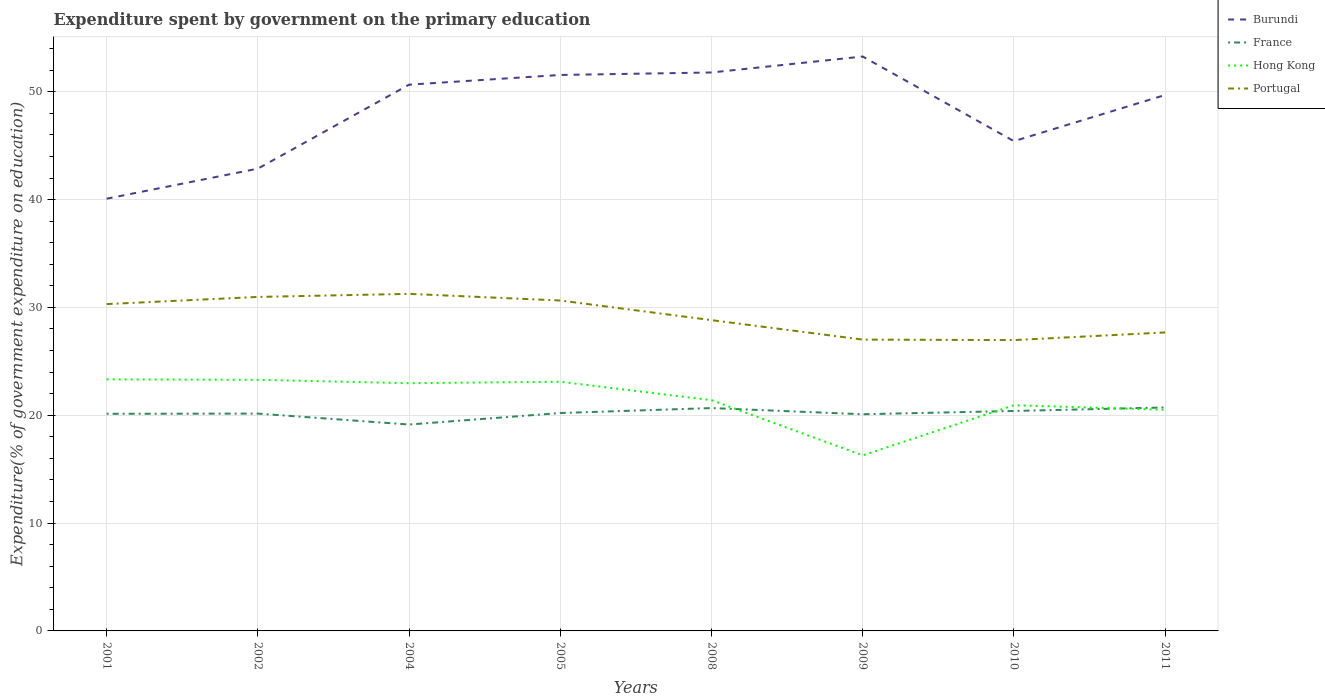Does the line corresponding to Portugal intersect with the line corresponding to Hong Kong?
Your answer should be compact. No. Is the number of lines equal to the number of legend labels?
Keep it short and to the point. Yes. Across all years, what is the maximum expenditure spent by government on the primary education in Burundi?
Provide a short and direct response. 40.08. What is the total expenditure spent by government on the primary education in Portugal in the graph?
Ensure brevity in your answer.  3.96. What is the difference between the highest and the second highest expenditure spent by government on the primary education in France?
Make the answer very short. 1.58. What is the difference between the highest and the lowest expenditure spent by government on the primary education in Hong Kong?
Your answer should be compact. 4. How many years are there in the graph?
Give a very brief answer. 8. What is the difference between two consecutive major ticks on the Y-axis?
Give a very brief answer. 10. Are the values on the major ticks of Y-axis written in scientific E-notation?
Keep it short and to the point. No. Does the graph contain any zero values?
Offer a very short reply. No. Does the graph contain grids?
Offer a terse response. Yes. Where does the legend appear in the graph?
Keep it short and to the point. Top right. What is the title of the graph?
Your response must be concise. Expenditure spent by government on the primary education. What is the label or title of the X-axis?
Your response must be concise. Years. What is the label or title of the Y-axis?
Your answer should be compact. Expenditure(% of government expenditure on education). What is the Expenditure(% of government expenditure on education) in Burundi in 2001?
Keep it short and to the point. 40.08. What is the Expenditure(% of government expenditure on education) of France in 2001?
Offer a very short reply. 20.13. What is the Expenditure(% of government expenditure on education) of Hong Kong in 2001?
Provide a short and direct response. 23.33. What is the Expenditure(% of government expenditure on education) of Portugal in 2001?
Your answer should be compact. 30.31. What is the Expenditure(% of government expenditure on education) of Burundi in 2002?
Provide a succinct answer. 42.87. What is the Expenditure(% of government expenditure on education) in France in 2002?
Keep it short and to the point. 20.15. What is the Expenditure(% of government expenditure on education) in Hong Kong in 2002?
Make the answer very short. 23.29. What is the Expenditure(% of government expenditure on education) in Portugal in 2002?
Ensure brevity in your answer.  30.97. What is the Expenditure(% of government expenditure on education) in Burundi in 2004?
Your response must be concise. 50.66. What is the Expenditure(% of government expenditure on education) of France in 2004?
Give a very brief answer. 19.14. What is the Expenditure(% of government expenditure on education) of Hong Kong in 2004?
Keep it short and to the point. 22.97. What is the Expenditure(% of government expenditure on education) of Portugal in 2004?
Offer a very short reply. 31.26. What is the Expenditure(% of government expenditure on education) of Burundi in 2005?
Provide a succinct answer. 51.56. What is the Expenditure(% of government expenditure on education) in France in 2005?
Your response must be concise. 20.21. What is the Expenditure(% of government expenditure on education) of Hong Kong in 2005?
Keep it short and to the point. 23.11. What is the Expenditure(% of government expenditure on education) in Portugal in 2005?
Keep it short and to the point. 30.64. What is the Expenditure(% of government expenditure on education) in Burundi in 2008?
Provide a short and direct response. 51.79. What is the Expenditure(% of government expenditure on education) in France in 2008?
Your response must be concise. 20.67. What is the Expenditure(% of government expenditure on education) in Hong Kong in 2008?
Your answer should be very brief. 21.4. What is the Expenditure(% of government expenditure on education) in Portugal in 2008?
Offer a terse response. 28.82. What is the Expenditure(% of government expenditure on education) of Burundi in 2009?
Make the answer very short. 53.27. What is the Expenditure(% of government expenditure on education) of France in 2009?
Provide a succinct answer. 20.09. What is the Expenditure(% of government expenditure on education) in Hong Kong in 2009?
Make the answer very short. 16.28. What is the Expenditure(% of government expenditure on education) of Portugal in 2009?
Provide a succinct answer. 27.02. What is the Expenditure(% of government expenditure on education) of Burundi in 2010?
Make the answer very short. 45.42. What is the Expenditure(% of government expenditure on education) in France in 2010?
Provide a short and direct response. 20.4. What is the Expenditure(% of government expenditure on education) in Hong Kong in 2010?
Your answer should be very brief. 20.93. What is the Expenditure(% of government expenditure on education) in Portugal in 2010?
Your answer should be very brief. 26.97. What is the Expenditure(% of government expenditure on education) in Burundi in 2011?
Your answer should be very brief. 49.7. What is the Expenditure(% of government expenditure on education) in France in 2011?
Make the answer very short. 20.72. What is the Expenditure(% of government expenditure on education) in Hong Kong in 2011?
Your answer should be compact. 20.51. What is the Expenditure(% of government expenditure on education) in Portugal in 2011?
Provide a short and direct response. 27.68. Across all years, what is the maximum Expenditure(% of government expenditure on education) in Burundi?
Give a very brief answer. 53.27. Across all years, what is the maximum Expenditure(% of government expenditure on education) in France?
Ensure brevity in your answer.  20.72. Across all years, what is the maximum Expenditure(% of government expenditure on education) of Hong Kong?
Keep it short and to the point. 23.33. Across all years, what is the maximum Expenditure(% of government expenditure on education) in Portugal?
Ensure brevity in your answer.  31.26. Across all years, what is the minimum Expenditure(% of government expenditure on education) of Burundi?
Your answer should be compact. 40.08. Across all years, what is the minimum Expenditure(% of government expenditure on education) of France?
Provide a short and direct response. 19.14. Across all years, what is the minimum Expenditure(% of government expenditure on education) in Hong Kong?
Offer a terse response. 16.28. Across all years, what is the minimum Expenditure(% of government expenditure on education) of Portugal?
Provide a short and direct response. 26.97. What is the total Expenditure(% of government expenditure on education) in Burundi in the graph?
Give a very brief answer. 385.34. What is the total Expenditure(% of government expenditure on education) in France in the graph?
Provide a short and direct response. 161.52. What is the total Expenditure(% of government expenditure on education) in Hong Kong in the graph?
Your response must be concise. 171.81. What is the total Expenditure(% of government expenditure on education) of Portugal in the graph?
Your answer should be very brief. 233.67. What is the difference between the Expenditure(% of government expenditure on education) of Burundi in 2001 and that in 2002?
Provide a short and direct response. -2.79. What is the difference between the Expenditure(% of government expenditure on education) of France in 2001 and that in 2002?
Offer a very short reply. -0.02. What is the difference between the Expenditure(% of government expenditure on education) of Hong Kong in 2001 and that in 2002?
Offer a terse response. 0.04. What is the difference between the Expenditure(% of government expenditure on education) of Portugal in 2001 and that in 2002?
Give a very brief answer. -0.66. What is the difference between the Expenditure(% of government expenditure on education) in Burundi in 2001 and that in 2004?
Ensure brevity in your answer.  -10.58. What is the difference between the Expenditure(% of government expenditure on education) in France in 2001 and that in 2004?
Your answer should be compact. 1. What is the difference between the Expenditure(% of government expenditure on education) in Hong Kong in 2001 and that in 2004?
Make the answer very short. 0.36. What is the difference between the Expenditure(% of government expenditure on education) of Portugal in 2001 and that in 2004?
Make the answer very short. -0.95. What is the difference between the Expenditure(% of government expenditure on education) in Burundi in 2001 and that in 2005?
Keep it short and to the point. -11.48. What is the difference between the Expenditure(% of government expenditure on education) in France in 2001 and that in 2005?
Your answer should be very brief. -0.07. What is the difference between the Expenditure(% of government expenditure on education) of Hong Kong in 2001 and that in 2005?
Make the answer very short. 0.22. What is the difference between the Expenditure(% of government expenditure on education) in Portugal in 2001 and that in 2005?
Your response must be concise. -0.33. What is the difference between the Expenditure(% of government expenditure on education) in Burundi in 2001 and that in 2008?
Make the answer very short. -11.71. What is the difference between the Expenditure(% of government expenditure on education) in France in 2001 and that in 2008?
Provide a short and direct response. -0.53. What is the difference between the Expenditure(% of government expenditure on education) of Hong Kong in 2001 and that in 2008?
Your answer should be very brief. 1.93. What is the difference between the Expenditure(% of government expenditure on education) in Portugal in 2001 and that in 2008?
Make the answer very short. 1.49. What is the difference between the Expenditure(% of government expenditure on education) of Burundi in 2001 and that in 2009?
Make the answer very short. -13.19. What is the difference between the Expenditure(% of government expenditure on education) in France in 2001 and that in 2009?
Give a very brief answer. 0.04. What is the difference between the Expenditure(% of government expenditure on education) of Hong Kong in 2001 and that in 2009?
Offer a terse response. 7.04. What is the difference between the Expenditure(% of government expenditure on education) in Portugal in 2001 and that in 2009?
Ensure brevity in your answer.  3.29. What is the difference between the Expenditure(% of government expenditure on education) in Burundi in 2001 and that in 2010?
Make the answer very short. -5.34. What is the difference between the Expenditure(% of government expenditure on education) of France in 2001 and that in 2010?
Offer a terse response. -0.26. What is the difference between the Expenditure(% of government expenditure on education) in Hong Kong in 2001 and that in 2010?
Your answer should be very brief. 2.4. What is the difference between the Expenditure(% of government expenditure on education) of Portugal in 2001 and that in 2010?
Offer a very short reply. 3.34. What is the difference between the Expenditure(% of government expenditure on education) of Burundi in 2001 and that in 2011?
Ensure brevity in your answer.  -9.62. What is the difference between the Expenditure(% of government expenditure on education) of France in 2001 and that in 2011?
Offer a very short reply. -0.59. What is the difference between the Expenditure(% of government expenditure on education) of Hong Kong in 2001 and that in 2011?
Your answer should be very brief. 2.82. What is the difference between the Expenditure(% of government expenditure on education) in Portugal in 2001 and that in 2011?
Keep it short and to the point. 2.63. What is the difference between the Expenditure(% of government expenditure on education) in Burundi in 2002 and that in 2004?
Your answer should be compact. -7.79. What is the difference between the Expenditure(% of government expenditure on education) in France in 2002 and that in 2004?
Keep it short and to the point. 1.01. What is the difference between the Expenditure(% of government expenditure on education) of Hong Kong in 2002 and that in 2004?
Provide a short and direct response. 0.31. What is the difference between the Expenditure(% of government expenditure on education) in Portugal in 2002 and that in 2004?
Make the answer very short. -0.28. What is the difference between the Expenditure(% of government expenditure on education) in Burundi in 2002 and that in 2005?
Give a very brief answer. -8.69. What is the difference between the Expenditure(% of government expenditure on education) in France in 2002 and that in 2005?
Your response must be concise. -0.05. What is the difference between the Expenditure(% of government expenditure on education) in Hong Kong in 2002 and that in 2005?
Give a very brief answer. 0.18. What is the difference between the Expenditure(% of government expenditure on education) in Portugal in 2002 and that in 2005?
Keep it short and to the point. 0.33. What is the difference between the Expenditure(% of government expenditure on education) of Burundi in 2002 and that in 2008?
Ensure brevity in your answer.  -8.92. What is the difference between the Expenditure(% of government expenditure on education) of France in 2002 and that in 2008?
Provide a short and direct response. -0.51. What is the difference between the Expenditure(% of government expenditure on education) in Hong Kong in 2002 and that in 2008?
Provide a succinct answer. 1.89. What is the difference between the Expenditure(% of government expenditure on education) of Portugal in 2002 and that in 2008?
Make the answer very short. 2.15. What is the difference between the Expenditure(% of government expenditure on education) in Burundi in 2002 and that in 2009?
Offer a very short reply. -10.4. What is the difference between the Expenditure(% of government expenditure on education) of France in 2002 and that in 2009?
Keep it short and to the point. 0.06. What is the difference between the Expenditure(% of government expenditure on education) of Hong Kong in 2002 and that in 2009?
Make the answer very short. 7. What is the difference between the Expenditure(% of government expenditure on education) of Portugal in 2002 and that in 2009?
Offer a terse response. 3.96. What is the difference between the Expenditure(% of government expenditure on education) of Burundi in 2002 and that in 2010?
Your answer should be very brief. -2.55. What is the difference between the Expenditure(% of government expenditure on education) in France in 2002 and that in 2010?
Your answer should be very brief. -0.24. What is the difference between the Expenditure(% of government expenditure on education) in Hong Kong in 2002 and that in 2010?
Your answer should be compact. 2.35. What is the difference between the Expenditure(% of government expenditure on education) of Portugal in 2002 and that in 2010?
Your answer should be very brief. 4. What is the difference between the Expenditure(% of government expenditure on education) in Burundi in 2002 and that in 2011?
Your answer should be very brief. -6.83. What is the difference between the Expenditure(% of government expenditure on education) in France in 2002 and that in 2011?
Your answer should be very brief. -0.57. What is the difference between the Expenditure(% of government expenditure on education) of Hong Kong in 2002 and that in 2011?
Offer a terse response. 2.78. What is the difference between the Expenditure(% of government expenditure on education) in Portugal in 2002 and that in 2011?
Your answer should be compact. 3.29. What is the difference between the Expenditure(% of government expenditure on education) in Burundi in 2004 and that in 2005?
Ensure brevity in your answer.  -0.9. What is the difference between the Expenditure(% of government expenditure on education) of France in 2004 and that in 2005?
Ensure brevity in your answer.  -1.07. What is the difference between the Expenditure(% of government expenditure on education) of Hong Kong in 2004 and that in 2005?
Your answer should be very brief. -0.13. What is the difference between the Expenditure(% of government expenditure on education) in Portugal in 2004 and that in 2005?
Ensure brevity in your answer.  0.62. What is the difference between the Expenditure(% of government expenditure on education) in Burundi in 2004 and that in 2008?
Provide a succinct answer. -1.13. What is the difference between the Expenditure(% of government expenditure on education) in France in 2004 and that in 2008?
Make the answer very short. -1.53. What is the difference between the Expenditure(% of government expenditure on education) in Hong Kong in 2004 and that in 2008?
Keep it short and to the point. 1.58. What is the difference between the Expenditure(% of government expenditure on education) of Portugal in 2004 and that in 2008?
Your answer should be compact. 2.44. What is the difference between the Expenditure(% of government expenditure on education) of Burundi in 2004 and that in 2009?
Make the answer very short. -2.61. What is the difference between the Expenditure(% of government expenditure on education) of France in 2004 and that in 2009?
Provide a short and direct response. -0.95. What is the difference between the Expenditure(% of government expenditure on education) of Hong Kong in 2004 and that in 2009?
Ensure brevity in your answer.  6.69. What is the difference between the Expenditure(% of government expenditure on education) in Portugal in 2004 and that in 2009?
Keep it short and to the point. 4.24. What is the difference between the Expenditure(% of government expenditure on education) in Burundi in 2004 and that in 2010?
Your answer should be compact. 5.24. What is the difference between the Expenditure(% of government expenditure on education) of France in 2004 and that in 2010?
Ensure brevity in your answer.  -1.26. What is the difference between the Expenditure(% of government expenditure on education) of Hong Kong in 2004 and that in 2010?
Make the answer very short. 2.04. What is the difference between the Expenditure(% of government expenditure on education) in Portugal in 2004 and that in 2010?
Keep it short and to the point. 4.29. What is the difference between the Expenditure(% of government expenditure on education) of Burundi in 2004 and that in 2011?
Offer a very short reply. 0.96. What is the difference between the Expenditure(% of government expenditure on education) in France in 2004 and that in 2011?
Your answer should be compact. -1.58. What is the difference between the Expenditure(% of government expenditure on education) in Hong Kong in 2004 and that in 2011?
Ensure brevity in your answer.  2.47. What is the difference between the Expenditure(% of government expenditure on education) in Portugal in 2004 and that in 2011?
Provide a short and direct response. 3.58. What is the difference between the Expenditure(% of government expenditure on education) of Burundi in 2005 and that in 2008?
Offer a terse response. -0.23. What is the difference between the Expenditure(% of government expenditure on education) in France in 2005 and that in 2008?
Provide a succinct answer. -0.46. What is the difference between the Expenditure(% of government expenditure on education) of Hong Kong in 2005 and that in 2008?
Keep it short and to the point. 1.71. What is the difference between the Expenditure(% of government expenditure on education) in Portugal in 2005 and that in 2008?
Keep it short and to the point. 1.82. What is the difference between the Expenditure(% of government expenditure on education) in Burundi in 2005 and that in 2009?
Offer a terse response. -1.71. What is the difference between the Expenditure(% of government expenditure on education) of France in 2005 and that in 2009?
Offer a terse response. 0.11. What is the difference between the Expenditure(% of government expenditure on education) of Hong Kong in 2005 and that in 2009?
Make the answer very short. 6.82. What is the difference between the Expenditure(% of government expenditure on education) of Portugal in 2005 and that in 2009?
Keep it short and to the point. 3.62. What is the difference between the Expenditure(% of government expenditure on education) of Burundi in 2005 and that in 2010?
Your answer should be very brief. 6.14. What is the difference between the Expenditure(% of government expenditure on education) in France in 2005 and that in 2010?
Your answer should be very brief. -0.19. What is the difference between the Expenditure(% of government expenditure on education) of Hong Kong in 2005 and that in 2010?
Provide a succinct answer. 2.18. What is the difference between the Expenditure(% of government expenditure on education) in Portugal in 2005 and that in 2010?
Your answer should be compact. 3.67. What is the difference between the Expenditure(% of government expenditure on education) in Burundi in 2005 and that in 2011?
Give a very brief answer. 1.86. What is the difference between the Expenditure(% of government expenditure on education) in France in 2005 and that in 2011?
Your answer should be very brief. -0.52. What is the difference between the Expenditure(% of government expenditure on education) in Hong Kong in 2005 and that in 2011?
Give a very brief answer. 2.6. What is the difference between the Expenditure(% of government expenditure on education) of Portugal in 2005 and that in 2011?
Provide a short and direct response. 2.96. What is the difference between the Expenditure(% of government expenditure on education) of Burundi in 2008 and that in 2009?
Your answer should be very brief. -1.48. What is the difference between the Expenditure(% of government expenditure on education) in France in 2008 and that in 2009?
Keep it short and to the point. 0.57. What is the difference between the Expenditure(% of government expenditure on education) of Hong Kong in 2008 and that in 2009?
Ensure brevity in your answer.  5.11. What is the difference between the Expenditure(% of government expenditure on education) of Portugal in 2008 and that in 2009?
Give a very brief answer. 1.81. What is the difference between the Expenditure(% of government expenditure on education) of Burundi in 2008 and that in 2010?
Give a very brief answer. 6.37. What is the difference between the Expenditure(% of government expenditure on education) in France in 2008 and that in 2010?
Offer a terse response. 0.27. What is the difference between the Expenditure(% of government expenditure on education) in Hong Kong in 2008 and that in 2010?
Your answer should be compact. 0.47. What is the difference between the Expenditure(% of government expenditure on education) in Portugal in 2008 and that in 2010?
Your answer should be compact. 1.85. What is the difference between the Expenditure(% of government expenditure on education) of Burundi in 2008 and that in 2011?
Offer a terse response. 2.09. What is the difference between the Expenditure(% of government expenditure on education) of France in 2008 and that in 2011?
Make the answer very short. -0.06. What is the difference between the Expenditure(% of government expenditure on education) in Hong Kong in 2008 and that in 2011?
Your response must be concise. 0.89. What is the difference between the Expenditure(% of government expenditure on education) of Portugal in 2008 and that in 2011?
Your answer should be compact. 1.14. What is the difference between the Expenditure(% of government expenditure on education) of Burundi in 2009 and that in 2010?
Offer a terse response. 7.85. What is the difference between the Expenditure(% of government expenditure on education) of France in 2009 and that in 2010?
Ensure brevity in your answer.  -0.31. What is the difference between the Expenditure(% of government expenditure on education) in Hong Kong in 2009 and that in 2010?
Make the answer very short. -4.65. What is the difference between the Expenditure(% of government expenditure on education) of Portugal in 2009 and that in 2010?
Provide a succinct answer. 0.04. What is the difference between the Expenditure(% of government expenditure on education) in Burundi in 2009 and that in 2011?
Your answer should be very brief. 3.57. What is the difference between the Expenditure(% of government expenditure on education) in France in 2009 and that in 2011?
Provide a succinct answer. -0.63. What is the difference between the Expenditure(% of government expenditure on education) of Hong Kong in 2009 and that in 2011?
Your answer should be very brief. -4.22. What is the difference between the Expenditure(% of government expenditure on education) in Portugal in 2009 and that in 2011?
Offer a very short reply. -0.66. What is the difference between the Expenditure(% of government expenditure on education) of Burundi in 2010 and that in 2011?
Your answer should be very brief. -4.28. What is the difference between the Expenditure(% of government expenditure on education) in France in 2010 and that in 2011?
Make the answer very short. -0.32. What is the difference between the Expenditure(% of government expenditure on education) of Hong Kong in 2010 and that in 2011?
Your answer should be compact. 0.42. What is the difference between the Expenditure(% of government expenditure on education) in Portugal in 2010 and that in 2011?
Offer a very short reply. -0.71. What is the difference between the Expenditure(% of government expenditure on education) of Burundi in 2001 and the Expenditure(% of government expenditure on education) of France in 2002?
Offer a terse response. 19.93. What is the difference between the Expenditure(% of government expenditure on education) of Burundi in 2001 and the Expenditure(% of government expenditure on education) of Hong Kong in 2002?
Offer a very short reply. 16.8. What is the difference between the Expenditure(% of government expenditure on education) in Burundi in 2001 and the Expenditure(% of government expenditure on education) in Portugal in 2002?
Provide a succinct answer. 9.11. What is the difference between the Expenditure(% of government expenditure on education) in France in 2001 and the Expenditure(% of government expenditure on education) in Hong Kong in 2002?
Give a very brief answer. -3.15. What is the difference between the Expenditure(% of government expenditure on education) of France in 2001 and the Expenditure(% of government expenditure on education) of Portugal in 2002?
Provide a succinct answer. -10.84. What is the difference between the Expenditure(% of government expenditure on education) of Hong Kong in 2001 and the Expenditure(% of government expenditure on education) of Portugal in 2002?
Your response must be concise. -7.65. What is the difference between the Expenditure(% of government expenditure on education) of Burundi in 2001 and the Expenditure(% of government expenditure on education) of France in 2004?
Provide a succinct answer. 20.94. What is the difference between the Expenditure(% of government expenditure on education) of Burundi in 2001 and the Expenditure(% of government expenditure on education) of Hong Kong in 2004?
Your answer should be compact. 17.11. What is the difference between the Expenditure(% of government expenditure on education) in Burundi in 2001 and the Expenditure(% of government expenditure on education) in Portugal in 2004?
Give a very brief answer. 8.83. What is the difference between the Expenditure(% of government expenditure on education) in France in 2001 and the Expenditure(% of government expenditure on education) in Hong Kong in 2004?
Your response must be concise. -2.84. What is the difference between the Expenditure(% of government expenditure on education) in France in 2001 and the Expenditure(% of government expenditure on education) in Portugal in 2004?
Provide a short and direct response. -11.12. What is the difference between the Expenditure(% of government expenditure on education) in Hong Kong in 2001 and the Expenditure(% of government expenditure on education) in Portugal in 2004?
Make the answer very short. -7.93. What is the difference between the Expenditure(% of government expenditure on education) of Burundi in 2001 and the Expenditure(% of government expenditure on education) of France in 2005?
Your response must be concise. 19.87. What is the difference between the Expenditure(% of government expenditure on education) of Burundi in 2001 and the Expenditure(% of government expenditure on education) of Hong Kong in 2005?
Ensure brevity in your answer.  16.97. What is the difference between the Expenditure(% of government expenditure on education) of Burundi in 2001 and the Expenditure(% of government expenditure on education) of Portugal in 2005?
Give a very brief answer. 9.44. What is the difference between the Expenditure(% of government expenditure on education) in France in 2001 and the Expenditure(% of government expenditure on education) in Hong Kong in 2005?
Provide a succinct answer. -2.97. What is the difference between the Expenditure(% of government expenditure on education) of France in 2001 and the Expenditure(% of government expenditure on education) of Portugal in 2005?
Make the answer very short. -10.51. What is the difference between the Expenditure(% of government expenditure on education) in Hong Kong in 2001 and the Expenditure(% of government expenditure on education) in Portugal in 2005?
Your response must be concise. -7.31. What is the difference between the Expenditure(% of government expenditure on education) of Burundi in 2001 and the Expenditure(% of government expenditure on education) of France in 2008?
Ensure brevity in your answer.  19.42. What is the difference between the Expenditure(% of government expenditure on education) in Burundi in 2001 and the Expenditure(% of government expenditure on education) in Hong Kong in 2008?
Provide a succinct answer. 18.68. What is the difference between the Expenditure(% of government expenditure on education) of Burundi in 2001 and the Expenditure(% of government expenditure on education) of Portugal in 2008?
Offer a terse response. 11.26. What is the difference between the Expenditure(% of government expenditure on education) of France in 2001 and the Expenditure(% of government expenditure on education) of Hong Kong in 2008?
Your answer should be very brief. -1.26. What is the difference between the Expenditure(% of government expenditure on education) of France in 2001 and the Expenditure(% of government expenditure on education) of Portugal in 2008?
Your answer should be compact. -8.69. What is the difference between the Expenditure(% of government expenditure on education) in Hong Kong in 2001 and the Expenditure(% of government expenditure on education) in Portugal in 2008?
Provide a short and direct response. -5.49. What is the difference between the Expenditure(% of government expenditure on education) in Burundi in 2001 and the Expenditure(% of government expenditure on education) in France in 2009?
Your answer should be very brief. 19.99. What is the difference between the Expenditure(% of government expenditure on education) in Burundi in 2001 and the Expenditure(% of government expenditure on education) in Hong Kong in 2009?
Offer a very short reply. 23.8. What is the difference between the Expenditure(% of government expenditure on education) in Burundi in 2001 and the Expenditure(% of government expenditure on education) in Portugal in 2009?
Offer a very short reply. 13.07. What is the difference between the Expenditure(% of government expenditure on education) in France in 2001 and the Expenditure(% of government expenditure on education) in Hong Kong in 2009?
Offer a very short reply. 3.85. What is the difference between the Expenditure(% of government expenditure on education) in France in 2001 and the Expenditure(% of government expenditure on education) in Portugal in 2009?
Give a very brief answer. -6.88. What is the difference between the Expenditure(% of government expenditure on education) of Hong Kong in 2001 and the Expenditure(% of government expenditure on education) of Portugal in 2009?
Provide a short and direct response. -3.69. What is the difference between the Expenditure(% of government expenditure on education) of Burundi in 2001 and the Expenditure(% of government expenditure on education) of France in 2010?
Keep it short and to the point. 19.68. What is the difference between the Expenditure(% of government expenditure on education) of Burundi in 2001 and the Expenditure(% of government expenditure on education) of Hong Kong in 2010?
Make the answer very short. 19.15. What is the difference between the Expenditure(% of government expenditure on education) in Burundi in 2001 and the Expenditure(% of government expenditure on education) in Portugal in 2010?
Your response must be concise. 13.11. What is the difference between the Expenditure(% of government expenditure on education) in France in 2001 and the Expenditure(% of government expenditure on education) in Hong Kong in 2010?
Ensure brevity in your answer.  -0.8. What is the difference between the Expenditure(% of government expenditure on education) in France in 2001 and the Expenditure(% of government expenditure on education) in Portugal in 2010?
Your response must be concise. -6.84. What is the difference between the Expenditure(% of government expenditure on education) of Hong Kong in 2001 and the Expenditure(% of government expenditure on education) of Portugal in 2010?
Your answer should be compact. -3.64. What is the difference between the Expenditure(% of government expenditure on education) of Burundi in 2001 and the Expenditure(% of government expenditure on education) of France in 2011?
Keep it short and to the point. 19.36. What is the difference between the Expenditure(% of government expenditure on education) of Burundi in 2001 and the Expenditure(% of government expenditure on education) of Hong Kong in 2011?
Your response must be concise. 19.58. What is the difference between the Expenditure(% of government expenditure on education) in Burundi in 2001 and the Expenditure(% of government expenditure on education) in Portugal in 2011?
Give a very brief answer. 12.4. What is the difference between the Expenditure(% of government expenditure on education) of France in 2001 and the Expenditure(% of government expenditure on education) of Hong Kong in 2011?
Provide a short and direct response. -0.37. What is the difference between the Expenditure(% of government expenditure on education) in France in 2001 and the Expenditure(% of government expenditure on education) in Portugal in 2011?
Provide a short and direct response. -7.54. What is the difference between the Expenditure(% of government expenditure on education) in Hong Kong in 2001 and the Expenditure(% of government expenditure on education) in Portugal in 2011?
Provide a short and direct response. -4.35. What is the difference between the Expenditure(% of government expenditure on education) in Burundi in 2002 and the Expenditure(% of government expenditure on education) in France in 2004?
Provide a short and direct response. 23.73. What is the difference between the Expenditure(% of government expenditure on education) of Burundi in 2002 and the Expenditure(% of government expenditure on education) of Hong Kong in 2004?
Your response must be concise. 19.9. What is the difference between the Expenditure(% of government expenditure on education) in Burundi in 2002 and the Expenditure(% of government expenditure on education) in Portugal in 2004?
Keep it short and to the point. 11.61. What is the difference between the Expenditure(% of government expenditure on education) in France in 2002 and the Expenditure(% of government expenditure on education) in Hong Kong in 2004?
Offer a very short reply. -2.82. What is the difference between the Expenditure(% of government expenditure on education) in France in 2002 and the Expenditure(% of government expenditure on education) in Portugal in 2004?
Offer a terse response. -11.1. What is the difference between the Expenditure(% of government expenditure on education) of Hong Kong in 2002 and the Expenditure(% of government expenditure on education) of Portugal in 2004?
Ensure brevity in your answer.  -7.97. What is the difference between the Expenditure(% of government expenditure on education) in Burundi in 2002 and the Expenditure(% of government expenditure on education) in France in 2005?
Your answer should be very brief. 22.66. What is the difference between the Expenditure(% of government expenditure on education) of Burundi in 2002 and the Expenditure(% of government expenditure on education) of Hong Kong in 2005?
Offer a terse response. 19.76. What is the difference between the Expenditure(% of government expenditure on education) in Burundi in 2002 and the Expenditure(% of government expenditure on education) in Portugal in 2005?
Your response must be concise. 12.23. What is the difference between the Expenditure(% of government expenditure on education) of France in 2002 and the Expenditure(% of government expenditure on education) of Hong Kong in 2005?
Keep it short and to the point. -2.95. What is the difference between the Expenditure(% of government expenditure on education) in France in 2002 and the Expenditure(% of government expenditure on education) in Portugal in 2005?
Offer a very short reply. -10.49. What is the difference between the Expenditure(% of government expenditure on education) of Hong Kong in 2002 and the Expenditure(% of government expenditure on education) of Portugal in 2005?
Ensure brevity in your answer.  -7.36. What is the difference between the Expenditure(% of government expenditure on education) in Burundi in 2002 and the Expenditure(% of government expenditure on education) in France in 2008?
Make the answer very short. 22.2. What is the difference between the Expenditure(% of government expenditure on education) of Burundi in 2002 and the Expenditure(% of government expenditure on education) of Hong Kong in 2008?
Your answer should be very brief. 21.47. What is the difference between the Expenditure(% of government expenditure on education) in Burundi in 2002 and the Expenditure(% of government expenditure on education) in Portugal in 2008?
Give a very brief answer. 14.05. What is the difference between the Expenditure(% of government expenditure on education) of France in 2002 and the Expenditure(% of government expenditure on education) of Hong Kong in 2008?
Offer a very short reply. -1.24. What is the difference between the Expenditure(% of government expenditure on education) of France in 2002 and the Expenditure(% of government expenditure on education) of Portugal in 2008?
Provide a succinct answer. -8.67. What is the difference between the Expenditure(% of government expenditure on education) of Hong Kong in 2002 and the Expenditure(% of government expenditure on education) of Portugal in 2008?
Keep it short and to the point. -5.54. What is the difference between the Expenditure(% of government expenditure on education) of Burundi in 2002 and the Expenditure(% of government expenditure on education) of France in 2009?
Your response must be concise. 22.78. What is the difference between the Expenditure(% of government expenditure on education) in Burundi in 2002 and the Expenditure(% of government expenditure on education) in Hong Kong in 2009?
Offer a very short reply. 26.59. What is the difference between the Expenditure(% of government expenditure on education) of Burundi in 2002 and the Expenditure(% of government expenditure on education) of Portugal in 2009?
Your response must be concise. 15.85. What is the difference between the Expenditure(% of government expenditure on education) in France in 2002 and the Expenditure(% of government expenditure on education) in Hong Kong in 2009?
Ensure brevity in your answer.  3.87. What is the difference between the Expenditure(% of government expenditure on education) of France in 2002 and the Expenditure(% of government expenditure on education) of Portugal in 2009?
Your answer should be compact. -6.86. What is the difference between the Expenditure(% of government expenditure on education) in Hong Kong in 2002 and the Expenditure(% of government expenditure on education) in Portugal in 2009?
Provide a succinct answer. -3.73. What is the difference between the Expenditure(% of government expenditure on education) of Burundi in 2002 and the Expenditure(% of government expenditure on education) of France in 2010?
Your answer should be compact. 22.47. What is the difference between the Expenditure(% of government expenditure on education) of Burundi in 2002 and the Expenditure(% of government expenditure on education) of Hong Kong in 2010?
Make the answer very short. 21.94. What is the difference between the Expenditure(% of government expenditure on education) of Burundi in 2002 and the Expenditure(% of government expenditure on education) of Portugal in 2010?
Your response must be concise. 15.9. What is the difference between the Expenditure(% of government expenditure on education) of France in 2002 and the Expenditure(% of government expenditure on education) of Hong Kong in 2010?
Make the answer very short. -0.78. What is the difference between the Expenditure(% of government expenditure on education) of France in 2002 and the Expenditure(% of government expenditure on education) of Portugal in 2010?
Provide a short and direct response. -6.82. What is the difference between the Expenditure(% of government expenditure on education) in Hong Kong in 2002 and the Expenditure(% of government expenditure on education) in Portugal in 2010?
Keep it short and to the point. -3.69. What is the difference between the Expenditure(% of government expenditure on education) of Burundi in 2002 and the Expenditure(% of government expenditure on education) of France in 2011?
Your answer should be very brief. 22.15. What is the difference between the Expenditure(% of government expenditure on education) of Burundi in 2002 and the Expenditure(% of government expenditure on education) of Hong Kong in 2011?
Ensure brevity in your answer.  22.36. What is the difference between the Expenditure(% of government expenditure on education) of Burundi in 2002 and the Expenditure(% of government expenditure on education) of Portugal in 2011?
Keep it short and to the point. 15.19. What is the difference between the Expenditure(% of government expenditure on education) of France in 2002 and the Expenditure(% of government expenditure on education) of Hong Kong in 2011?
Your answer should be compact. -0.35. What is the difference between the Expenditure(% of government expenditure on education) in France in 2002 and the Expenditure(% of government expenditure on education) in Portugal in 2011?
Offer a very short reply. -7.53. What is the difference between the Expenditure(% of government expenditure on education) of Hong Kong in 2002 and the Expenditure(% of government expenditure on education) of Portugal in 2011?
Your response must be concise. -4.39. What is the difference between the Expenditure(% of government expenditure on education) of Burundi in 2004 and the Expenditure(% of government expenditure on education) of France in 2005?
Your answer should be compact. 30.45. What is the difference between the Expenditure(% of government expenditure on education) of Burundi in 2004 and the Expenditure(% of government expenditure on education) of Hong Kong in 2005?
Offer a very short reply. 27.55. What is the difference between the Expenditure(% of government expenditure on education) of Burundi in 2004 and the Expenditure(% of government expenditure on education) of Portugal in 2005?
Provide a succinct answer. 20.02. What is the difference between the Expenditure(% of government expenditure on education) of France in 2004 and the Expenditure(% of government expenditure on education) of Hong Kong in 2005?
Provide a short and direct response. -3.97. What is the difference between the Expenditure(% of government expenditure on education) in France in 2004 and the Expenditure(% of government expenditure on education) in Portugal in 2005?
Your answer should be compact. -11.5. What is the difference between the Expenditure(% of government expenditure on education) of Hong Kong in 2004 and the Expenditure(% of government expenditure on education) of Portugal in 2005?
Keep it short and to the point. -7.67. What is the difference between the Expenditure(% of government expenditure on education) of Burundi in 2004 and the Expenditure(% of government expenditure on education) of France in 2008?
Offer a very short reply. 29.99. What is the difference between the Expenditure(% of government expenditure on education) of Burundi in 2004 and the Expenditure(% of government expenditure on education) of Hong Kong in 2008?
Provide a short and direct response. 29.26. What is the difference between the Expenditure(% of government expenditure on education) in Burundi in 2004 and the Expenditure(% of government expenditure on education) in Portugal in 2008?
Your response must be concise. 21.84. What is the difference between the Expenditure(% of government expenditure on education) in France in 2004 and the Expenditure(% of government expenditure on education) in Hong Kong in 2008?
Provide a short and direct response. -2.26. What is the difference between the Expenditure(% of government expenditure on education) in France in 2004 and the Expenditure(% of government expenditure on education) in Portugal in 2008?
Provide a succinct answer. -9.68. What is the difference between the Expenditure(% of government expenditure on education) of Hong Kong in 2004 and the Expenditure(% of government expenditure on education) of Portugal in 2008?
Offer a very short reply. -5.85. What is the difference between the Expenditure(% of government expenditure on education) of Burundi in 2004 and the Expenditure(% of government expenditure on education) of France in 2009?
Make the answer very short. 30.56. What is the difference between the Expenditure(% of government expenditure on education) of Burundi in 2004 and the Expenditure(% of government expenditure on education) of Hong Kong in 2009?
Keep it short and to the point. 34.37. What is the difference between the Expenditure(% of government expenditure on education) of Burundi in 2004 and the Expenditure(% of government expenditure on education) of Portugal in 2009?
Ensure brevity in your answer.  23.64. What is the difference between the Expenditure(% of government expenditure on education) of France in 2004 and the Expenditure(% of government expenditure on education) of Hong Kong in 2009?
Provide a succinct answer. 2.86. What is the difference between the Expenditure(% of government expenditure on education) of France in 2004 and the Expenditure(% of government expenditure on education) of Portugal in 2009?
Keep it short and to the point. -7.88. What is the difference between the Expenditure(% of government expenditure on education) of Hong Kong in 2004 and the Expenditure(% of government expenditure on education) of Portugal in 2009?
Your response must be concise. -4.04. What is the difference between the Expenditure(% of government expenditure on education) of Burundi in 2004 and the Expenditure(% of government expenditure on education) of France in 2010?
Keep it short and to the point. 30.26. What is the difference between the Expenditure(% of government expenditure on education) of Burundi in 2004 and the Expenditure(% of government expenditure on education) of Hong Kong in 2010?
Provide a short and direct response. 29.73. What is the difference between the Expenditure(% of government expenditure on education) in Burundi in 2004 and the Expenditure(% of government expenditure on education) in Portugal in 2010?
Ensure brevity in your answer.  23.69. What is the difference between the Expenditure(% of government expenditure on education) of France in 2004 and the Expenditure(% of government expenditure on education) of Hong Kong in 2010?
Provide a short and direct response. -1.79. What is the difference between the Expenditure(% of government expenditure on education) in France in 2004 and the Expenditure(% of government expenditure on education) in Portugal in 2010?
Offer a terse response. -7.83. What is the difference between the Expenditure(% of government expenditure on education) in Hong Kong in 2004 and the Expenditure(% of government expenditure on education) in Portugal in 2010?
Your answer should be compact. -4. What is the difference between the Expenditure(% of government expenditure on education) of Burundi in 2004 and the Expenditure(% of government expenditure on education) of France in 2011?
Your answer should be very brief. 29.93. What is the difference between the Expenditure(% of government expenditure on education) of Burundi in 2004 and the Expenditure(% of government expenditure on education) of Hong Kong in 2011?
Give a very brief answer. 30.15. What is the difference between the Expenditure(% of government expenditure on education) in Burundi in 2004 and the Expenditure(% of government expenditure on education) in Portugal in 2011?
Your answer should be compact. 22.98. What is the difference between the Expenditure(% of government expenditure on education) in France in 2004 and the Expenditure(% of government expenditure on education) in Hong Kong in 2011?
Provide a short and direct response. -1.37. What is the difference between the Expenditure(% of government expenditure on education) of France in 2004 and the Expenditure(% of government expenditure on education) of Portugal in 2011?
Keep it short and to the point. -8.54. What is the difference between the Expenditure(% of government expenditure on education) in Hong Kong in 2004 and the Expenditure(% of government expenditure on education) in Portugal in 2011?
Your answer should be very brief. -4.71. What is the difference between the Expenditure(% of government expenditure on education) of Burundi in 2005 and the Expenditure(% of government expenditure on education) of France in 2008?
Your answer should be very brief. 30.89. What is the difference between the Expenditure(% of government expenditure on education) in Burundi in 2005 and the Expenditure(% of government expenditure on education) in Hong Kong in 2008?
Offer a terse response. 30.16. What is the difference between the Expenditure(% of government expenditure on education) in Burundi in 2005 and the Expenditure(% of government expenditure on education) in Portugal in 2008?
Offer a very short reply. 22.74. What is the difference between the Expenditure(% of government expenditure on education) in France in 2005 and the Expenditure(% of government expenditure on education) in Hong Kong in 2008?
Provide a succinct answer. -1.19. What is the difference between the Expenditure(% of government expenditure on education) in France in 2005 and the Expenditure(% of government expenditure on education) in Portugal in 2008?
Your response must be concise. -8.61. What is the difference between the Expenditure(% of government expenditure on education) in Hong Kong in 2005 and the Expenditure(% of government expenditure on education) in Portugal in 2008?
Keep it short and to the point. -5.71. What is the difference between the Expenditure(% of government expenditure on education) in Burundi in 2005 and the Expenditure(% of government expenditure on education) in France in 2009?
Make the answer very short. 31.46. What is the difference between the Expenditure(% of government expenditure on education) of Burundi in 2005 and the Expenditure(% of government expenditure on education) of Hong Kong in 2009?
Ensure brevity in your answer.  35.27. What is the difference between the Expenditure(% of government expenditure on education) in Burundi in 2005 and the Expenditure(% of government expenditure on education) in Portugal in 2009?
Ensure brevity in your answer.  24.54. What is the difference between the Expenditure(% of government expenditure on education) in France in 2005 and the Expenditure(% of government expenditure on education) in Hong Kong in 2009?
Your response must be concise. 3.92. What is the difference between the Expenditure(% of government expenditure on education) in France in 2005 and the Expenditure(% of government expenditure on education) in Portugal in 2009?
Your answer should be compact. -6.81. What is the difference between the Expenditure(% of government expenditure on education) in Hong Kong in 2005 and the Expenditure(% of government expenditure on education) in Portugal in 2009?
Make the answer very short. -3.91. What is the difference between the Expenditure(% of government expenditure on education) in Burundi in 2005 and the Expenditure(% of government expenditure on education) in France in 2010?
Keep it short and to the point. 31.16. What is the difference between the Expenditure(% of government expenditure on education) in Burundi in 2005 and the Expenditure(% of government expenditure on education) in Hong Kong in 2010?
Offer a terse response. 30.63. What is the difference between the Expenditure(% of government expenditure on education) of Burundi in 2005 and the Expenditure(% of government expenditure on education) of Portugal in 2010?
Keep it short and to the point. 24.59. What is the difference between the Expenditure(% of government expenditure on education) in France in 2005 and the Expenditure(% of government expenditure on education) in Hong Kong in 2010?
Your answer should be compact. -0.72. What is the difference between the Expenditure(% of government expenditure on education) in France in 2005 and the Expenditure(% of government expenditure on education) in Portugal in 2010?
Provide a succinct answer. -6.76. What is the difference between the Expenditure(% of government expenditure on education) of Hong Kong in 2005 and the Expenditure(% of government expenditure on education) of Portugal in 2010?
Provide a short and direct response. -3.86. What is the difference between the Expenditure(% of government expenditure on education) of Burundi in 2005 and the Expenditure(% of government expenditure on education) of France in 2011?
Make the answer very short. 30.83. What is the difference between the Expenditure(% of government expenditure on education) in Burundi in 2005 and the Expenditure(% of government expenditure on education) in Hong Kong in 2011?
Ensure brevity in your answer.  31.05. What is the difference between the Expenditure(% of government expenditure on education) in Burundi in 2005 and the Expenditure(% of government expenditure on education) in Portugal in 2011?
Give a very brief answer. 23.88. What is the difference between the Expenditure(% of government expenditure on education) of France in 2005 and the Expenditure(% of government expenditure on education) of Hong Kong in 2011?
Provide a succinct answer. -0.3. What is the difference between the Expenditure(% of government expenditure on education) of France in 2005 and the Expenditure(% of government expenditure on education) of Portugal in 2011?
Provide a succinct answer. -7.47. What is the difference between the Expenditure(% of government expenditure on education) of Hong Kong in 2005 and the Expenditure(% of government expenditure on education) of Portugal in 2011?
Your answer should be compact. -4.57. What is the difference between the Expenditure(% of government expenditure on education) in Burundi in 2008 and the Expenditure(% of government expenditure on education) in France in 2009?
Give a very brief answer. 31.69. What is the difference between the Expenditure(% of government expenditure on education) of Burundi in 2008 and the Expenditure(% of government expenditure on education) of Hong Kong in 2009?
Your answer should be compact. 35.5. What is the difference between the Expenditure(% of government expenditure on education) of Burundi in 2008 and the Expenditure(% of government expenditure on education) of Portugal in 2009?
Provide a short and direct response. 24.77. What is the difference between the Expenditure(% of government expenditure on education) in France in 2008 and the Expenditure(% of government expenditure on education) in Hong Kong in 2009?
Ensure brevity in your answer.  4.38. What is the difference between the Expenditure(% of government expenditure on education) of France in 2008 and the Expenditure(% of government expenditure on education) of Portugal in 2009?
Your answer should be very brief. -6.35. What is the difference between the Expenditure(% of government expenditure on education) of Hong Kong in 2008 and the Expenditure(% of government expenditure on education) of Portugal in 2009?
Your answer should be compact. -5.62. What is the difference between the Expenditure(% of government expenditure on education) of Burundi in 2008 and the Expenditure(% of government expenditure on education) of France in 2010?
Offer a very short reply. 31.39. What is the difference between the Expenditure(% of government expenditure on education) of Burundi in 2008 and the Expenditure(% of government expenditure on education) of Hong Kong in 2010?
Offer a terse response. 30.86. What is the difference between the Expenditure(% of government expenditure on education) in Burundi in 2008 and the Expenditure(% of government expenditure on education) in Portugal in 2010?
Give a very brief answer. 24.82. What is the difference between the Expenditure(% of government expenditure on education) of France in 2008 and the Expenditure(% of government expenditure on education) of Hong Kong in 2010?
Ensure brevity in your answer.  -0.26. What is the difference between the Expenditure(% of government expenditure on education) of France in 2008 and the Expenditure(% of government expenditure on education) of Portugal in 2010?
Make the answer very short. -6.3. What is the difference between the Expenditure(% of government expenditure on education) of Hong Kong in 2008 and the Expenditure(% of government expenditure on education) of Portugal in 2010?
Give a very brief answer. -5.57. What is the difference between the Expenditure(% of government expenditure on education) of Burundi in 2008 and the Expenditure(% of government expenditure on education) of France in 2011?
Your answer should be very brief. 31.06. What is the difference between the Expenditure(% of government expenditure on education) of Burundi in 2008 and the Expenditure(% of government expenditure on education) of Hong Kong in 2011?
Offer a very short reply. 31.28. What is the difference between the Expenditure(% of government expenditure on education) in Burundi in 2008 and the Expenditure(% of government expenditure on education) in Portugal in 2011?
Provide a short and direct response. 24.11. What is the difference between the Expenditure(% of government expenditure on education) of France in 2008 and the Expenditure(% of government expenditure on education) of Hong Kong in 2011?
Your answer should be very brief. 0.16. What is the difference between the Expenditure(% of government expenditure on education) in France in 2008 and the Expenditure(% of government expenditure on education) in Portugal in 2011?
Your answer should be very brief. -7.01. What is the difference between the Expenditure(% of government expenditure on education) in Hong Kong in 2008 and the Expenditure(% of government expenditure on education) in Portugal in 2011?
Offer a terse response. -6.28. What is the difference between the Expenditure(% of government expenditure on education) in Burundi in 2009 and the Expenditure(% of government expenditure on education) in France in 2010?
Keep it short and to the point. 32.87. What is the difference between the Expenditure(% of government expenditure on education) in Burundi in 2009 and the Expenditure(% of government expenditure on education) in Hong Kong in 2010?
Offer a very short reply. 32.34. What is the difference between the Expenditure(% of government expenditure on education) of Burundi in 2009 and the Expenditure(% of government expenditure on education) of Portugal in 2010?
Keep it short and to the point. 26.3. What is the difference between the Expenditure(% of government expenditure on education) of France in 2009 and the Expenditure(% of government expenditure on education) of Hong Kong in 2010?
Ensure brevity in your answer.  -0.84. What is the difference between the Expenditure(% of government expenditure on education) of France in 2009 and the Expenditure(% of government expenditure on education) of Portugal in 2010?
Provide a succinct answer. -6.88. What is the difference between the Expenditure(% of government expenditure on education) of Hong Kong in 2009 and the Expenditure(% of government expenditure on education) of Portugal in 2010?
Provide a succinct answer. -10.69. What is the difference between the Expenditure(% of government expenditure on education) of Burundi in 2009 and the Expenditure(% of government expenditure on education) of France in 2011?
Offer a terse response. 32.54. What is the difference between the Expenditure(% of government expenditure on education) of Burundi in 2009 and the Expenditure(% of government expenditure on education) of Hong Kong in 2011?
Your answer should be very brief. 32.76. What is the difference between the Expenditure(% of government expenditure on education) of Burundi in 2009 and the Expenditure(% of government expenditure on education) of Portugal in 2011?
Provide a short and direct response. 25.59. What is the difference between the Expenditure(% of government expenditure on education) of France in 2009 and the Expenditure(% of government expenditure on education) of Hong Kong in 2011?
Your answer should be very brief. -0.41. What is the difference between the Expenditure(% of government expenditure on education) of France in 2009 and the Expenditure(% of government expenditure on education) of Portugal in 2011?
Make the answer very short. -7.59. What is the difference between the Expenditure(% of government expenditure on education) in Hong Kong in 2009 and the Expenditure(% of government expenditure on education) in Portugal in 2011?
Ensure brevity in your answer.  -11.4. What is the difference between the Expenditure(% of government expenditure on education) of Burundi in 2010 and the Expenditure(% of government expenditure on education) of France in 2011?
Keep it short and to the point. 24.7. What is the difference between the Expenditure(% of government expenditure on education) of Burundi in 2010 and the Expenditure(% of government expenditure on education) of Hong Kong in 2011?
Make the answer very short. 24.91. What is the difference between the Expenditure(% of government expenditure on education) of Burundi in 2010 and the Expenditure(% of government expenditure on education) of Portugal in 2011?
Your answer should be compact. 17.74. What is the difference between the Expenditure(% of government expenditure on education) of France in 2010 and the Expenditure(% of government expenditure on education) of Hong Kong in 2011?
Your response must be concise. -0.11. What is the difference between the Expenditure(% of government expenditure on education) in France in 2010 and the Expenditure(% of government expenditure on education) in Portugal in 2011?
Offer a very short reply. -7.28. What is the difference between the Expenditure(% of government expenditure on education) in Hong Kong in 2010 and the Expenditure(% of government expenditure on education) in Portugal in 2011?
Give a very brief answer. -6.75. What is the average Expenditure(% of government expenditure on education) in Burundi per year?
Provide a short and direct response. 48.17. What is the average Expenditure(% of government expenditure on education) in France per year?
Provide a short and direct response. 20.19. What is the average Expenditure(% of government expenditure on education) in Hong Kong per year?
Provide a short and direct response. 21.48. What is the average Expenditure(% of government expenditure on education) of Portugal per year?
Your response must be concise. 29.21. In the year 2001, what is the difference between the Expenditure(% of government expenditure on education) in Burundi and Expenditure(% of government expenditure on education) in France?
Provide a succinct answer. 19.95. In the year 2001, what is the difference between the Expenditure(% of government expenditure on education) of Burundi and Expenditure(% of government expenditure on education) of Hong Kong?
Offer a very short reply. 16.75. In the year 2001, what is the difference between the Expenditure(% of government expenditure on education) of Burundi and Expenditure(% of government expenditure on education) of Portugal?
Ensure brevity in your answer.  9.77. In the year 2001, what is the difference between the Expenditure(% of government expenditure on education) of France and Expenditure(% of government expenditure on education) of Hong Kong?
Offer a terse response. -3.19. In the year 2001, what is the difference between the Expenditure(% of government expenditure on education) in France and Expenditure(% of government expenditure on education) in Portugal?
Your response must be concise. -10.17. In the year 2001, what is the difference between the Expenditure(% of government expenditure on education) of Hong Kong and Expenditure(% of government expenditure on education) of Portugal?
Offer a very short reply. -6.98. In the year 2002, what is the difference between the Expenditure(% of government expenditure on education) in Burundi and Expenditure(% of government expenditure on education) in France?
Provide a succinct answer. 22.71. In the year 2002, what is the difference between the Expenditure(% of government expenditure on education) of Burundi and Expenditure(% of government expenditure on education) of Hong Kong?
Your response must be concise. 19.58. In the year 2002, what is the difference between the Expenditure(% of government expenditure on education) in Burundi and Expenditure(% of government expenditure on education) in Portugal?
Ensure brevity in your answer.  11.9. In the year 2002, what is the difference between the Expenditure(% of government expenditure on education) in France and Expenditure(% of government expenditure on education) in Hong Kong?
Provide a short and direct response. -3.13. In the year 2002, what is the difference between the Expenditure(% of government expenditure on education) of France and Expenditure(% of government expenditure on education) of Portugal?
Offer a very short reply. -10.82. In the year 2002, what is the difference between the Expenditure(% of government expenditure on education) in Hong Kong and Expenditure(% of government expenditure on education) in Portugal?
Keep it short and to the point. -7.69. In the year 2004, what is the difference between the Expenditure(% of government expenditure on education) of Burundi and Expenditure(% of government expenditure on education) of France?
Provide a short and direct response. 31.52. In the year 2004, what is the difference between the Expenditure(% of government expenditure on education) of Burundi and Expenditure(% of government expenditure on education) of Hong Kong?
Make the answer very short. 27.68. In the year 2004, what is the difference between the Expenditure(% of government expenditure on education) of Burundi and Expenditure(% of government expenditure on education) of Portugal?
Offer a very short reply. 19.4. In the year 2004, what is the difference between the Expenditure(% of government expenditure on education) in France and Expenditure(% of government expenditure on education) in Hong Kong?
Provide a succinct answer. -3.83. In the year 2004, what is the difference between the Expenditure(% of government expenditure on education) of France and Expenditure(% of government expenditure on education) of Portugal?
Provide a short and direct response. -12.12. In the year 2004, what is the difference between the Expenditure(% of government expenditure on education) of Hong Kong and Expenditure(% of government expenditure on education) of Portugal?
Make the answer very short. -8.28. In the year 2005, what is the difference between the Expenditure(% of government expenditure on education) of Burundi and Expenditure(% of government expenditure on education) of France?
Your response must be concise. 31.35. In the year 2005, what is the difference between the Expenditure(% of government expenditure on education) of Burundi and Expenditure(% of government expenditure on education) of Hong Kong?
Provide a succinct answer. 28.45. In the year 2005, what is the difference between the Expenditure(% of government expenditure on education) of Burundi and Expenditure(% of government expenditure on education) of Portugal?
Provide a succinct answer. 20.92. In the year 2005, what is the difference between the Expenditure(% of government expenditure on education) of France and Expenditure(% of government expenditure on education) of Hong Kong?
Make the answer very short. -2.9. In the year 2005, what is the difference between the Expenditure(% of government expenditure on education) of France and Expenditure(% of government expenditure on education) of Portugal?
Make the answer very short. -10.43. In the year 2005, what is the difference between the Expenditure(% of government expenditure on education) of Hong Kong and Expenditure(% of government expenditure on education) of Portugal?
Give a very brief answer. -7.53. In the year 2008, what is the difference between the Expenditure(% of government expenditure on education) in Burundi and Expenditure(% of government expenditure on education) in France?
Your response must be concise. 31.12. In the year 2008, what is the difference between the Expenditure(% of government expenditure on education) in Burundi and Expenditure(% of government expenditure on education) in Hong Kong?
Make the answer very short. 30.39. In the year 2008, what is the difference between the Expenditure(% of government expenditure on education) of Burundi and Expenditure(% of government expenditure on education) of Portugal?
Keep it short and to the point. 22.97. In the year 2008, what is the difference between the Expenditure(% of government expenditure on education) of France and Expenditure(% of government expenditure on education) of Hong Kong?
Give a very brief answer. -0.73. In the year 2008, what is the difference between the Expenditure(% of government expenditure on education) of France and Expenditure(% of government expenditure on education) of Portugal?
Your response must be concise. -8.15. In the year 2008, what is the difference between the Expenditure(% of government expenditure on education) of Hong Kong and Expenditure(% of government expenditure on education) of Portugal?
Offer a terse response. -7.42. In the year 2009, what is the difference between the Expenditure(% of government expenditure on education) in Burundi and Expenditure(% of government expenditure on education) in France?
Provide a succinct answer. 33.17. In the year 2009, what is the difference between the Expenditure(% of government expenditure on education) in Burundi and Expenditure(% of government expenditure on education) in Hong Kong?
Provide a succinct answer. 36.98. In the year 2009, what is the difference between the Expenditure(% of government expenditure on education) of Burundi and Expenditure(% of government expenditure on education) of Portugal?
Offer a very short reply. 26.25. In the year 2009, what is the difference between the Expenditure(% of government expenditure on education) of France and Expenditure(% of government expenditure on education) of Hong Kong?
Give a very brief answer. 3.81. In the year 2009, what is the difference between the Expenditure(% of government expenditure on education) of France and Expenditure(% of government expenditure on education) of Portugal?
Your response must be concise. -6.92. In the year 2009, what is the difference between the Expenditure(% of government expenditure on education) of Hong Kong and Expenditure(% of government expenditure on education) of Portugal?
Provide a short and direct response. -10.73. In the year 2010, what is the difference between the Expenditure(% of government expenditure on education) of Burundi and Expenditure(% of government expenditure on education) of France?
Provide a succinct answer. 25.02. In the year 2010, what is the difference between the Expenditure(% of government expenditure on education) in Burundi and Expenditure(% of government expenditure on education) in Hong Kong?
Ensure brevity in your answer.  24.49. In the year 2010, what is the difference between the Expenditure(% of government expenditure on education) of Burundi and Expenditure(% of government expenditure on education) of Portugal?
Ensure brevity in your answer.  18.45. In the year 2010, what is the difference between the Expenditure(% of government expenditure on education) of France and Expenditure(% of government expenditure on education) of Hong Kong?
Your answer should be very brief. -0.53. In the year 2010, what is the difference between the Expenditure(% of government expenditure on education) of France and Expenditure(% of government expenditure on education) of Portugal?
Offer a very short reply. -6.57. In the year 2010, what is the difference between the Expenditure(% of government expenditure on education) of Hong Kong and Expenditure(% of government expenditure on education) of Portugal?
Offer a terse response. -6.04. In the year 2011, what is the difference between the Expenditure(% of government expenditure on education) in Burundi and Expenditure(% of government expenditure on education) in France?
Give a very brief answer. 28.98. In the year 2011, what is the difference between the Expenditure(% of government expenditure on education) in Burundi and Expenditure(% of government expenditure on education) in Hong Kong?
Your answer should be very brief. 29.19. In the year 2011, what is the difference between the Expenditure(% of government expenditure on education) in Burundi and Expenditure(% of government expenditure on education) in Portugal?
Your answer should be very brief. 22.02. In the year 2011, what is the difference between the Expenditure(% of government expenditure on education) of France and Expenditure(% of government expenditure on education) of Hong Kong?
Provide a succinct answer. 0.22. In the year 2011, what is the difference between the Expenditure(% of government expenditure on education) of France and Expenditure(% of government expenditure on education) of Portugal?
Provide a succinct answer. -6.96. In the year 2011, what is the difference between the Expenditure(% of government expenditure on education) of Hong Kong and Expenditure(% of government expenditure on education) of Portugal?
Offer a terse response. -7.17. What is the ratio of the Expenditure(% of government expenditure on education) in Burundi in 2001 to that in 2002?
Keep it short and to the point. 0.94. What is the ratio of the Expenditure(% of government expenditure on education) in France in 2001 to that in 2002?
Provide a succinct answer. 1. What is the ratio of the Expenditure(% of government expenditure on education) in Hong Kong in 2001 to that in 2002?
Ensure brevity in your answer.  1. What is the ratio of the Expenditure(% of government expenditure on education) in Portugal in 2001 to that in 2002?
Make the answer very short. 0.98. What is the ratio of the Expenditure(% of government expenditure on education) of Burundi in 2001 to that in 2004?
Provide a short and direct response. 0.79. What is the ratio of the Expenditure(% of government expenditure on education) of France in 2001 to that in 2004?
Your answer should be very brief. 1.05. What is the ratio of the Expenditure(% of government expenditure on education) in Hong Kong in 2001 to that in 2004?
Your answer should be compact. 1.02. What is the ratio of the Expenditure(% of government expenditure on education) of Portugal in 2001 to that in 2004?
Make the answer very short. 0.97. What is the ratio of the Expenditure(% of government expenditure on education) in Burundi in 2001 to that in 2005?
Your answer should be very brief. 0.78. What is the ratio of the Expenditure(% of government expenditure on education) of Hong Kong in 2001 to that in 2005?
Your answer should be compact. 1.01. What is the ratio of the Expenditure(% of government expenditure on education) in Burundi in 2001 to that in 2008?
Your answer should be very brief. 0.77. What is the ratio of the Expenditure(% of government expenditure on education) in France in 2001 to that in 2008?
Your answer should be compact. 0.97. What is the ratio of the Expenditure(% of government expenditure on education) of Hong Kong in 2001 to that in 2008?
Provide a succinct answer. 1.09. What is the ratio of the Expenditure(% of government expenditure on education) of Portugal in 2001 to that in 2008?
Give a very brief answer. 1.05. What is the ratio of the Expenditure(% of government expenditure on education) in Burundi in 2001 to that in 2009?
Offer a terse response. 0.75. What is the ratio of the Expenditure(% of government expenditure on education) of France in 2001 to that in 2009?
Your answer should be compact. 1. What is the ratio of the Expenditure(% of government expenditure on education) in Hong Kong in 2001 to that in 2009?
Offer a terse response. 1.43. What is the ratio of the Expenditure(% of government expenditure on education) in Portugal in 2001 to that in 2009?
Offer a very short reply. 1.12. What is the ratio of the Expenditure(% of government expenditure on education) in Burundi in 2001 to that in 2010?
Give a very brief answer. 0.88. What is the ratio of the Expenditure(% of government expenditure on education) in France in 2001 to that in 2010?
Your answer should be compact. 0.99. What is the ratio of the Expenditure(% of government expenditure on education) in Hong Kong in 2001 to that in 2010?
Your answer should be very brief. 1.11. What is the ratio of the Expenditure(% of government expenditure on education) of Portugal in 2001 to that in 2010?
Your answer should be very brief. 1.12. What is the ratio of the Expenditure(% of government expenditure on education) of Burundi in 2001 to that in 2011?
Your response must be concise. 0.81. What is the ratio of the Expenditure(% of government expenditure on education) in France in 2001 to that in 2011?
Provide a succinct answer. 0.97. What is the ratio of the Expenditure(% of government expenditure on education) in Hong Kong in 2001 to that in 2011?
Give a very brief answer. 1.14. What is the ratio of the Expenditure(% of government expenditure on education) in Portugal in 2001 to that in 2011?
Provide a short and direct response. 1.09. What is the ratio of the Expenditure(% of government expenditure on education) in Burundi in 2002 to that in 2004?
Your response must be concise. 0.85. What is the ratio of the Expenditure(% of government expenditure on education) of France in 2002 to that in 2004?
Provide a succinct answer. 1.05. What is the ratio of the Expenditure(% of government expenditure on education) of Hong Kong in 2002 to that in 2004?
Provide a short and direct response. 1.01. What is the ratio of the Expenditure(% of government expenditure on education) in Portugal in 2002 to that in 2004?
Make the answer very short. 0.99. What is the ratio of the Expenditure(% of government expenditure on education) in Burundi in 2002 to that in 2005?
Your response must be concise. 0.83. What is the ratio of the Expenditure(% of government expenditure on education) in France in 2002 to that in 2005?
Make the answer very short. 1. What is the ratio of the Expenditure(% of government expenditure on education) of Hong Kong in 2002 to that in 2005?
Your response must be concise. 1.01. What is the ratio of the Expenditure(% of government expenditure on education) of Portugal in 2002 to that in 2005?
Give a very brief answer. 1.01. What is the ratio of the Expenditure(% of government expenditure on education) of Burundi in 2002 to that in 2008?
Your response must be concise. 0.83. What is the ratio of the Expenditure(% of government expenditure on education) in France in 2002 to that in 2008?
Make the answer very short. 0.98. What is the ratio of the Expenditure(% of government expenditure on education) of Hong Kong in 2002 to that in 2008?
Your answer should be very brief. 1.09. What is the ratio of the Expenditure(% of government expenditure on education) in Portugal in 2002 to that in 2008?
Keep it short and to the point. 1.07. What is the ratio of the Expenditure(% of government expenditure on education) in Burundi in 2002 to that in 2009?
Keep it short and to the point. 0.8. What is the ratio of the Expenditure(% of government expenditure on education) in Hong Kong in 2002 to that in 2009?
Your response must be concise. 1.43. What is the ratio of the Expenditure(% of government expenditure on education) of Portugal in 2002 to that in 2009?
Make the answer very short. 1.15. What is the ratio of the Expenditure(% of government expenditure on education) of Burundi in 2002 to that in 2010?
Your response must be concise. 0.94. What is the ratio of the Expenditure(% of government expenditure on education) of France in 2002 to that in 2010?
Provide a short and direct response. 0.99. What is the ratio of the Expenditure(% of government expenditure on education) in Hong Kong in 2002 to that in 2010?
Make the answer very short. 1.11. What is the ratio of the Expenditure(% of government expenditure on education) in Portugal in 2002 to that in 2010?
Make the answer very short. 1.15. What is the ratio of the Expenditure(% of government expenditure on education) in Burundi in 2002 to that in 2011?
Ensure brevity in your answer.  0.86. What is the ratio of the Expenditure(% of government expenditure on education) in France in 2002 to that in 2011?
Your answer should be compact. 0.97. What is the ratio of the Expenditure(% of government expenditure on education) of Hong Kong in 2002 to that in 2011?
Give a very brief answer. 1.14. What is the ratio of the Expenditure(% of government expenditure on education) in Portugal in 2002 to that in 2011?
Ensure brevity in your answer.  1.12. What is the ratio of the Expenditure(% of government expenditure on education) of Burundi in 2004 to that in 2005?
Offer a very short reply. 0.98. What is the ratio of the Expenditure(% of government expenditure on education) of France in 2004 to that in 2005?
Keep it short and to the point. 0.95. What is the ratio of the Expenditure(% of government expenditure on education) of Portugal in 2004 to that in 2005?
Make the answer very short. 1.02. What is the ratio of the Expenditure(% of government expenditure on education) of Burundi in 2004 to that in 2008?
Your answer should be very brief. 0.98. What is the ratio of the Expenditure(% of government expenditure on education) of France in 2004 to that in 2008?
Keep it short and to the point. 0.93. What is the ratio of the Expenditure(% of government expenditure on education) in Hong Kong in 2004 to that in 2008?
Provide a succinct answer. 1.07. What is the ratio of the Expenditure(% of government expenditure on education) of Portugal in 2004 to that in 2008?
Make the answer very short. 1.08. What is the ratio of the Expenditure(% of government expenditure on education) of Burundi in 2004 to that in 2009?
Your answer should be compact. 0.95. What is the ratio of the Expenditure(% of government expenditure on education) of France in 2004 to that in 2009?
Your answer should be compact. 0.95. What is the ratio of the Expenditure(% of government expenditure on education) of Hong Kong in 2004 to that in 2009?
Give a very brief answer. 1.41. What is the ratio of the Expenditure(% of government expenditure on education) in Portugal in 2004 to that in 2009?
Your answer should be compact. 1.16. What is the ratio of the Expenditure(% of government expenditure on education) of Burundi in 2004 to that in 2010?
Offer a very short reply. 1.12. What is the ratio of the Expenditure(% of government expenditure on education) in France in 2004 to that in 2010?
Your response must be concise. 0.94. What is the ratio of the Expenditure(% of government expenditure on education) in Hong Kong in 2004 to that in 2010?
Keep it short and to the point. 1.1. What is the ratio of the Expenditure(% of government expenditure on education) of Portugal in 2004 to that in 2010?
Your answer should be very brief. 1.16. What is the ratio of the Expenditure(% of government expenditure on education) in Burundi in 2004 to that in 2011?
Keep it short and to the point. 1.02. What is the ratio of the Expenditure(% of government expenditure on education) of France in 2004 to that in 2011?
Keep it short and to the point. 0.92. What is the ratio of the Expenditure(% of government expenditure on education) in Hong Kong in 2004 to that in 2011?
Your response must be concise. 1.12. What is the ratio of the Expenditure(% of government expenditure on education) in Portugal in 2004 to that in 2011?
Ensure brevity in your answer.  1.13. What is the ratio of the Expenditure(% of government expenditure on education) in France in 2005 to that in 2008?
Your response must be concise. 0.98. What is the ratio of the Expenditure(% of government expenditure on education) in Hong Kong in 2005 to that in 2008?
Give a very brief answer. 1.08. What is the ratio of the Expenditure(% of government expenditure on education) in Portugal in 2005 to that in 2008?
Ensure brevity in your answer.  1.06. What is the ratio of the Expenditure(% of government expenditure on education) in Burundi in 2005 to that in 2009?
Provide a succinct answer. 0.97. What is the ratio of the Expenditure(% of government expenditure on education) of France in 2005 to that in 2009?
Your response must be concise. 1.01. What is the ratio of the Expenditure(% of government expenditure on education) in Hong Kong in 2005 to that in 2009?
Provide a short and direct response. 1.42. What is the ratio of the Expenditure(% of government expenditure on education) of Portugal in 2005 to that in 2009?
Keep it short and to the point. 1.13. What is the ratio of the Expenditure(% of government expenditure on education) in Burundi in 2005 to that in 2010?
Keep it short and to the point. 1.14. What is the ratio of the Expenditure(% of government expenditure on education) of Hong Kong in 2005 to that in 2010?
Your response must be concise. 1.1. What is the ratio of the Expenditure(% of government expenditure on education) of Portugal in 2005 to that in 2010?
Your response must be concise. 1.14. What is the ratio of the Expenditure(% of government expenditure on education) in Burundi in 2005 to that in 2011?
Make the answer very short. 1.04. What is the ratio of the Expenditure(% of government expenditure on education) of France in 2005 to that in 2011?
Provide a short and direct response. 0.98. What is the ratio of the Expenditure(% of government expenditure on education) of Hong Kong in 2005 to that in 2011?
Offer a very short reply. 1.13. What is the ratio of the Expenditure(% of government expenditure on education) of Portugal in 2005 to that in 2011?
Give a very brief answer. 1.11. What is the ratio of the Expenditure(% of government expenditure on education) of Burundi in 2008 to that in 2009?
Provide a short and direct response. 0.97. What is the ratio of the Expenditure(% of government expenditure on education) in France in 2008 to that in 2009?
Offer a very short reply. 1.03. What is the ratio of the Expenditure(% of government expenditure on education) in Hong Kong in 2008 to that in 2009?
Offer a terse response. 1.31. What is the ratio of the Expenditure(% of government expenditure on education) in Portugal in 2008 to that in 2009?
Offer a very short reply. 1.07. What is the ratio of the Expenditure(% of government expenditure on education) in Burundi in 2008 to that in 2010?
Ensure brevity in your answer.  1.14. What is the ratio of the Expenditure(% of government expenditure on education) in France in 2008 to that in 2010?
Ensure brevity in your answer.  1.01. What is the ratio of the Expenditure(% of government expenditure on education) in Hong Kong in 2008 to that in 2010?
Your answer should be compact. 1.02. What is the ratio of the Expenditure(% of government expenditure on education) in Portugal in 2008 to that in 2010?
Make the answer very short. 1.07. What is the ratio of the Expenditure(% of government expenditure on education) in Burundi in 2008 to that in 2011?
Ensure brevity in your answer.  1.04. What is the ratio of the Expenditure(% of government expenditure on education) in Hong Kong in 2008 to that in 2011?
Offer a very short reply. 1.04. What is the ratio of the Expenditure(% of government expenditure on education) in Portugal in 2008 to that in 2011?
Give a very brief answer. 1.04. What is the ratio of the Expenditure(% of government expenditure on education) of Burundi in 2009 to that in 2010?
Make the answer very short. 1.17. What is the ratio of the Expenditure(% of government expenditure on education) of Hong Kong in 2009 to that in 2010?
Your answer should be very brief. 0.78. What is the ratio of the Expenditure(% of government expenditure on education) of Portugal in 2009 to that in 2010?
Provide a succinct answer. 1. What is the ratio of the Expenditure(% of government expenditure on education) in Burundi in 2009 to that in 2011?
Give a very brief answer. 1.07. What is the ratio of the Expenditure(% of government expenditure on education) of France in 2009 to that in 2011?
Offer a terse response. 0.97. What is the ratio of the Expenditure(% of government expenditure on education) in Hong Kong in 2009 to that in 2011?
Your answer should be compact. 0.79. What is the ratio of the Expenditure(% of government expenditure on education) of Burundi in 2010 to that in 2011?
Give a very brief answer. 0.91. What is the ratio of the Expenditure(% of government expenditure on education) in France in 2010 to that in 2011?
Give a very brief answer. 0.98. What is the ratio of the Expenditure(% of government expenditure on education) in Hong Kong in 2010 to that in 2011?
Provide a short and direct response. 1.02. What is the ratio of the Expenditure(% of government expenditure on education) of Portugal in 2010 to that in 2011?
Offer a very short reply. 0.97. What is the difference between the highest and the second highest Expenditure(% of government expenditure on education) of Burundi?
Offer a very short reply. 1.48. What is the difference between the highest and the second highest Expenditure(% of government expenditure on education) in France?
Give a very brief answer. 0.06. What is the difference between the highest and the second highest Expenditure(% of government expenditure on education) of Hong Kong?
Provide a succinct answer. 0.04. What is the difference between the highest and the second highest Expenditure(% of government expenditure on education) of Portugal?
Offer a terse response. 0.28. What is the difference between the highest and the lowest Expenditure(% of government expenditure on education) in Burundi?
Provide a short and direct response. 13.19. What is the difference between the highest and the lowest Expenditure(% of government expenditure on education) of France?
Your response must be concise. 1.58. What is the difference between the highest and the lowest Expenditure(% of government expenditure on education) in Hong Kong?
Make the answer very short. 7.04. What is the difference between the highest and the lowest Expenditure(% of government expenditure on education) in Portugal?
Provide a short and direct response. 4.29. 